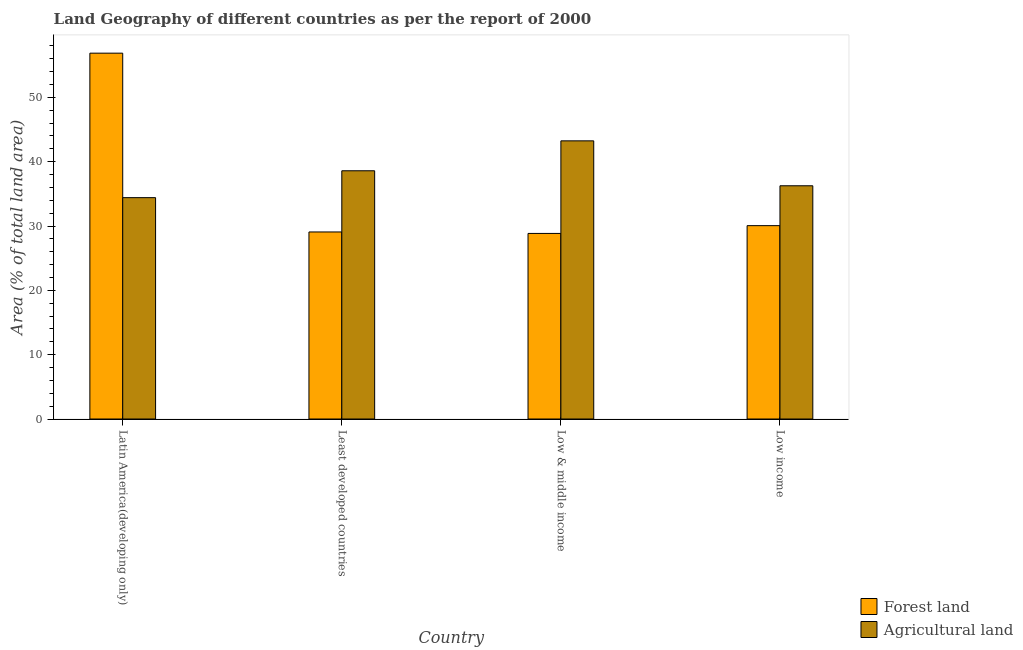How many different coloured bars are there?
Ensure brevity in your answer.  2. Are the number of bars per tick equal to the number of legend labels?
Your response must be concise. Yes. Are the number of bars on each tick of the X-axis equal?
Offer a very short reply. Yes. How many bars are there on the 4th tick from the left?
Your answer should be compact. 2. How many bars are there on the 3rd tick from the right?
Offer a very short reply. 2. What is the label of the 4th group of bars from the left?
Your response must be concise. Low income. What is the percentage of land area under agriculture in Least developed countries?
Your response must be concise. 38.59. Across all countries, what is the maximum percentage of land area under forests?
Give a very brief answer. 56.87. Across all countries, what is the minimum percentage of land area under forests?
Your answer should be compact. 28.85. In which country was the percentage of land area under agriculture maximum?
Provide a short and direct response. Low & middle income. What is the total percentage of land area under agriculture in the graph?
Ensure brevity in your answer.  152.49. What is the difference between the percentage of land area under forests in Least developed countries and that in Low & middle income?
Keep it short and to the point. 0.23. What is the difference between the percentage of land area under agriculture in Low income and the percentage of land area under forests in Low & middle income?
Your response must be concise. 7.41. What is the average percentage of land area under forests per country?
Give a very brief answer. 36.21. What is the difference between the percentage of land area under forests and percentage of land area under agriculture in Low & middle income?
Keep it short and to the point. -14.39. What is the ratio of the percentage of land area under forests in Latin America(developing only) to that in Low income?
Provide a short and direct response. 1.89. What is the difference between the highest and the second highest percentage of land area under forests?
Offer a terse response. 26.81. What is the difference between the highest and the lowest percentage of land area under forests?
Offer a terse response. 28.02. In how many countries, is the percentage of land area under forests greater than the average percentage of land area under forests taken over all countries?
Keep it short and to the point. 1. Is the sum of the percentage of land area under forests in Latin America(developing only) and Low income greater than the maximum percentage of land area under agriculture across all countries?
Give a very brief answer. Yes. What does the 2nd bar from the left in Low & middle income represents?
Your answer should be very brief. Agricultural land. What does the 1st bar from the right in Low & middle income represents?
Ensure brevity in your answer.  Agricultural land. Are all the bars in the graph horizontal?
Make the answer very short. No. Where does the legend appear in the graph?
Provide a short and direct response. Bottom right. How many legend labels are there?
Provide a succinct answer. 2. What is the title of the graph?
Provide a short and direct response. Land Geography of different countries as per the report of 2000. What is the label or title of the X-axis?
Your answer should be very brief. Country. What is the label or title of the Y-axis?
Provide a short and direct response. Area (% of total land area). What is the Area (% of total land area) in Forest land in Latin America(developing only)?
Give a very brief answer. 56.87. What is the Area (% of total land area) of Agricultural land in Latin America(developing only)?
Ensure brevity in your answer.  34.41. What is the Area (% of total land area) in Forest land in Least developed countries?
Offer a very short reply. 29.08. What is the Area (% of total land area) of Agricultural land in Least developed countries?
Your response must be concise. 38.59. What is the Area (% of total land area) in Forest land in Low & middle income?
Provide a succinct answer. 28.85. What is the Area (% of total land area) of Agricultural land in Low & middle income?
Give a very brief answer. 43.24. What is the Area (% of total land area) of Forest land in Low income?
Offer a very short reply. 30.06. What is the Area (% of total land area) of Agricultural land in Low income?
Make the answer very short. 36.25. Across all countries, what is the maximum Area (% of total land area) in Forest land?
Provide a succinct answer. 56.87. Across all countries, what is the maximum Area (% of total land area) of Agricultural land?
Your response must be concise. 43.24. Across all countries, what is the minimum Area (% of total land area) of Forest land?
Your answer should be very brief. 28.85. Across all countries, what is the minimum Area (% of total land area) in Agricultural land?
Your answer should be compact. 34.41. What is the total Area (% of total land area) of Forest land in the graph?
Make the answer very short. 144.85. What is the total Area (% of total land area) in Agricultural land in the graph?
Give a very brief answer. 152.49. What is the difference between the Area (% of total land area) of Forest land in Latin America(developing only) and that in Least developed countries?
Your answer should be very brief. 27.79. What is the difference between the Area (% of total land area) of Agricultural land in Latin America(developing only) and that in Least developed countries?
Your answer should be very brief. -4.18. What is the difference between the Area (% of total land area) in Forest land in Latin America(developing only) and that in Low & middle income?
Ensure brevity in your answer.  28.02. What is the difference between the Area (% of total land area) in Agricultural land in Latin America(developing only) and that in Low & middle income?
Offer a terse response. -8.83. What is the difference between the Area (% of total land area) of Forest land in Latin America(developing only) and that in Low income?
Make the answer very short. 26.81. What is the difference between the Area (% of total land area) of Agricultural land in Latin America(developing only) and that in Low income?
Keep it short and to the point. -1.84. What is the difference between the Area (% of total land area) of Forest land in Least developed countries and that in Low & middle income?
Your response must be concise. 0.23. What is the difference between the Area (% of total land area) in Agricultural land in Least developed countries and that in Low & middle income?
Your response must be concise. -4.65. What is the difference between the Area (% of total land area) in Forest land in Least developed countries and that in Low income?
Your answer should be compact. -0.98. What is the difference between the Area (% of total land area) of Agricultural land in Least developed countries and that in Low income?
Provide a short and direct response. 2.33. What is the difference between the Area (% of total land area) of Forest land in Low & middle income and that in Low income?
Offer a very short reply. -1.21. What is the difference between the Area (% of total land area) in Agricultural land in Low & middle income and that in Low income?
Offer a very short reply. 6.98. What is the difference between the Area (% of total land area) of Forest land in Latin America(developing only) and the Area (% of total land area) of Agricultural land in Least developed countries?
Your answer should be compact. 18.28. What is the difference between the Area (% of total land area) of Forest land in Latin America(developing only) and the Area (% of total land area) of Agricultural land in Low & middle income?
Your answer should be compact. 13.63. What is the difference between the Area (% of total land area) in Forest land in Latin America(developing only) and the Area (% of total land area) in Agricultural land in Low income?
Ensure brevity in your answer.  20.61. What is the difference between the Area (% of total land area) in Forest land in Least developed countries and the Area (% of total land area) in Agricultural land in Low & middle income?
Offer a terse response. -14.16. What is the difference between the Area (% of total land area) of Forest land in Least developed countries and the Area (% of total land area) of Agricultural land in Low income?
Give a very brief answer. -7.18. What is the difference between the Area (% of total land area) of Forest land in Low & middle income and the Area (% of total land area) of Agricultural land in Low income?
Offer a terse response. -7.41. What is the average Area (% of total land area) in Forest land per country?
Offer a terse response. 36.21. What is the average Area (% of total land area) of Agricultural land per country?
Your answer should be very brief. 38.12. What is the difference between the Area (% of total land area) of Forest land and Area (% of total land area) of Agricultural land in Latin America(developing only)?
Make the answer very short. 22.46. What is the difference between the Area (% of total land area) of Forest land and Area (% of total land area) of Agricultural land in Least developed countries?
Keep it short and to the point. -9.51. What is the difference between the Area (% of total land area) in Forest land and Area (% of total land area) in Agricultural land in Low & middle income?
Your answer should be compact. -14.39. What is the difference between the Area (% of total land area) of Forest land and Area (% of total land area) of Agricultural land in Low income?
Offer a terse response. -6.2. What is the ratio of the Area (% of total land area) of Forest land in Latin America(developing only) to that in Least developed countries?
Keep it short and to the point. 1.96. What is the ratio of the Area (% of total land area) of Agricultural land in Latin America(developing only) to that in Least developed countries?
Your answer should be compact. 0.89. What is the ratio of the Area (% of total land area) of Forest land in Latin America(developing only) to that in Low & middle income?
Your answer should be compact. 1.97. What is the ratio of the Area (% of total land area) in Agricultural land in Latin America(developing only) to that in Low & middle income?
Make the answer very short. 0.8. What is the ratio of the Area (% of total land area) of Forest land in Latin America(developing only) to that in Low income?
Provide a succinct answer. 1.89. What is the ratio of the Area (% of total land area) in Agricultural land in Latin America(developing only) to that in Low income?
Your answer should be very brief. 0.95. What is the ratio of the Area (% of total land area) in Forest land in Least developed countries to that in Low & middle income?
Your response must be concise. 1.01. What is the ratio of the Area (% of total land area) of Agricultural land in Least developed countries to that in Low & middle income?
Provide a succinct answer. 0.89. What is the ratio of the Area (% of total land area) of Forest land in Least developed countries to that in Low income?
Your response must be concise. 0.97. What is the ratio of the Area (% of total land area) of Agricultural land in Least developed countries to that in Low income?
Your answer should be compact. 1.06. What is the ratio of the Area (% of total land area) in Forest land in Low & middle income to that in Low income?
Make the answer very short. 0.96. What is the ratio of the Area (% of total land area) in Agricultural land in Low & middle income to that in Low income?
Ensure brevity in your answer.  1.19. What is the difference between the highest and the second highest Area (% of total land area) of Forest land?
Make the answer very short. 26.81. What is the difference between the highest and the second highest Area (% of total land area) in Agricultural land?
Your answer should be compact. 4.65. What is the difference between the highest and the lowest Area (% of total land area) in Forest land?
Offer a very short reply. 28.02. What is the difference between the highest and the lowest Area (% of total land area) in Agricultural land?
Ensure brevity in your answer.  8.83. 